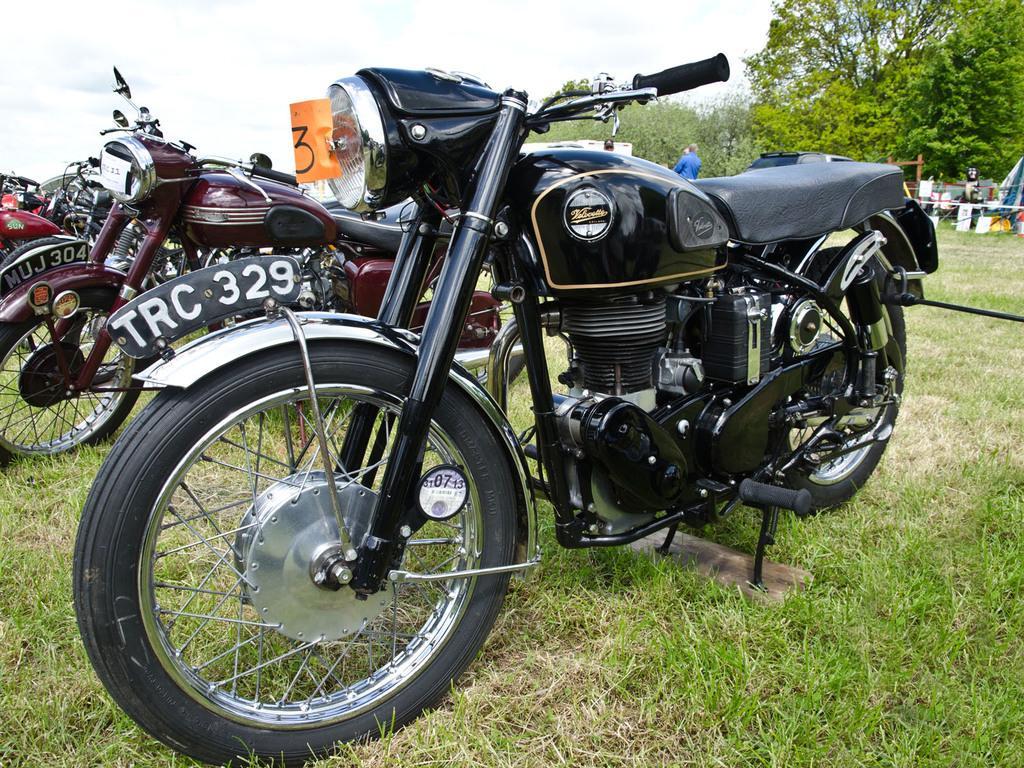Can you describe this image briefly? in the given picture a garden and i can see three vehicles which is available in the garden and also behind the vehicles i can see person standing after that i can see trees and also i can few objects. 